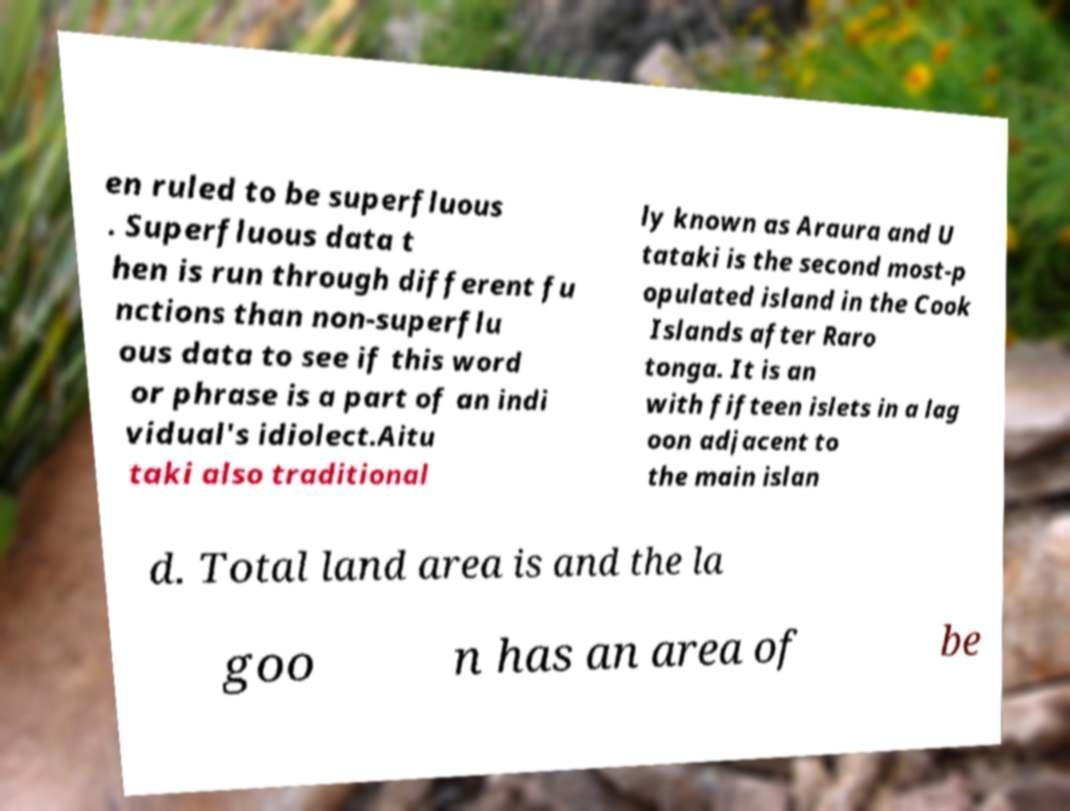I need the written content from this picture converted into text. Can you do that? en ruled to be superfluous . Superfluous data t hen is run through different fu nctions than non-superflu ous data to see if this word or phrase is a part of an indi vidual's idiolect.Aitu taki also traditional ly known as Araura and U tataki is the second most-p opulated island in the Cook Islands after Raro tonga. It is an with fifteen islets in a lag oon adjacent to the main islan d. Total land area is and the la goo n has an area of be 